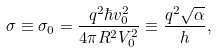Convert formula to latex. <formula><loc_0><loc_0><loc_500><loc_500>\sigma \equiv \sigma _ { 0 } = \frac { q ^ { 2 } \hbar { v } _ { 0 } ^ { 2 } } { 4 \pi R ^ { 2 } V _ { 0 } ^ { 2 } } \equiv \frac { q ^ { 2 } \sqrt { \alpha } } { h } ,</formula> 